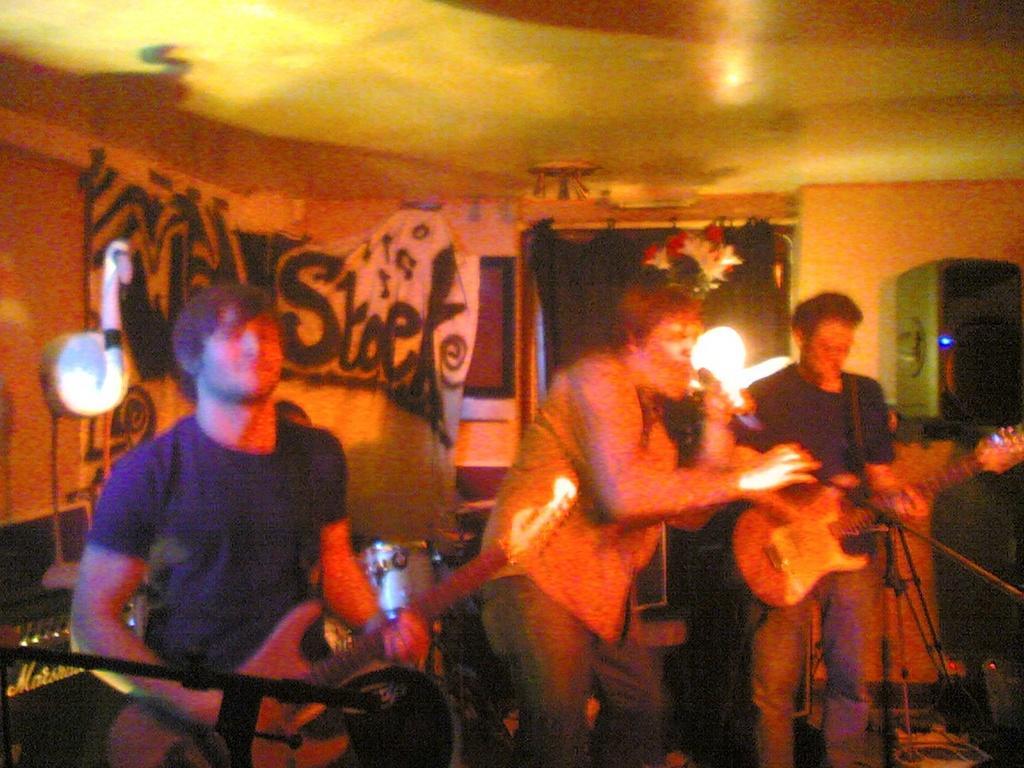Describe this image in one or two sentences. In this image I can see three men. Two are playing guitars and one man is singing a song by holding a mike in his hand. In the background I can see a wall and one window. There are some curtains as well. 